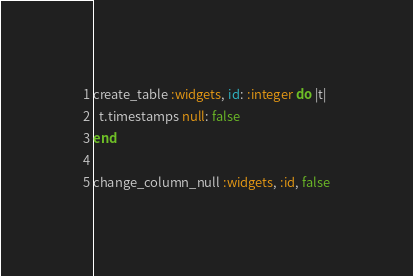<code> <loc_0><loc_0><loc_500><loc_500><_Ruby_>create_table :widgets, id: :integer do |t|
  t.timestamps null: false
end

change_column_null :widgets, :id, false
</code> 